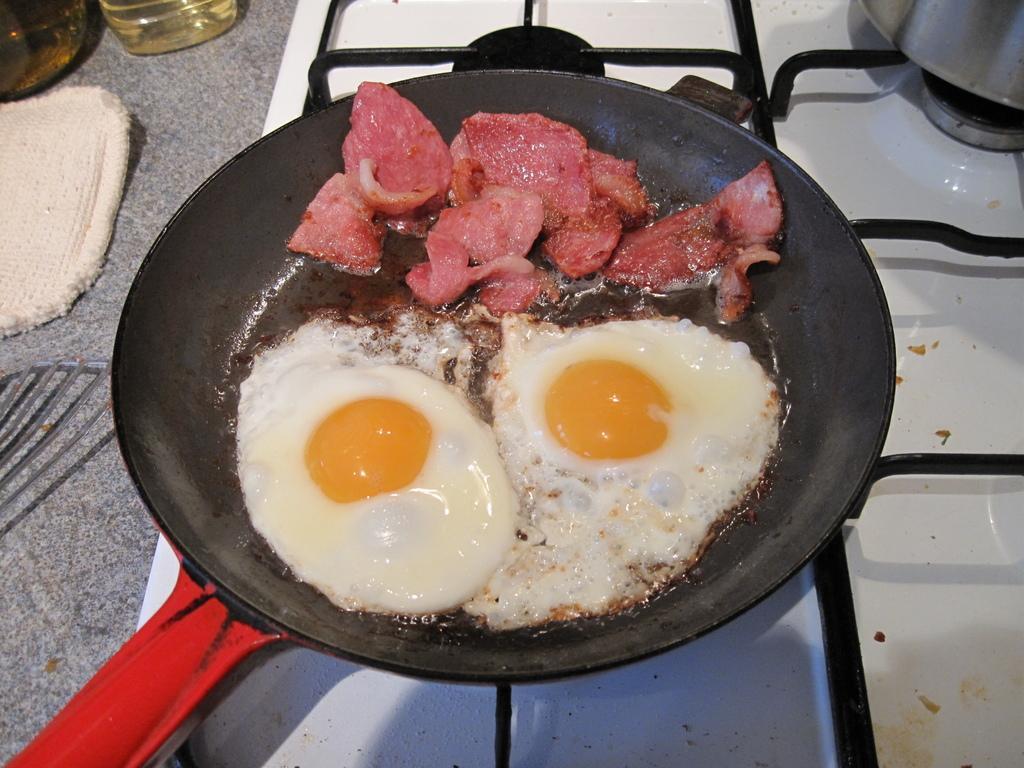How would you summarize this image in a sentence or two? In the picture we can see a stove with a pan and on the pan we can see two half boiled eggs and some slices of meat and near the stove we can see some cloth and a bottle with oil. 